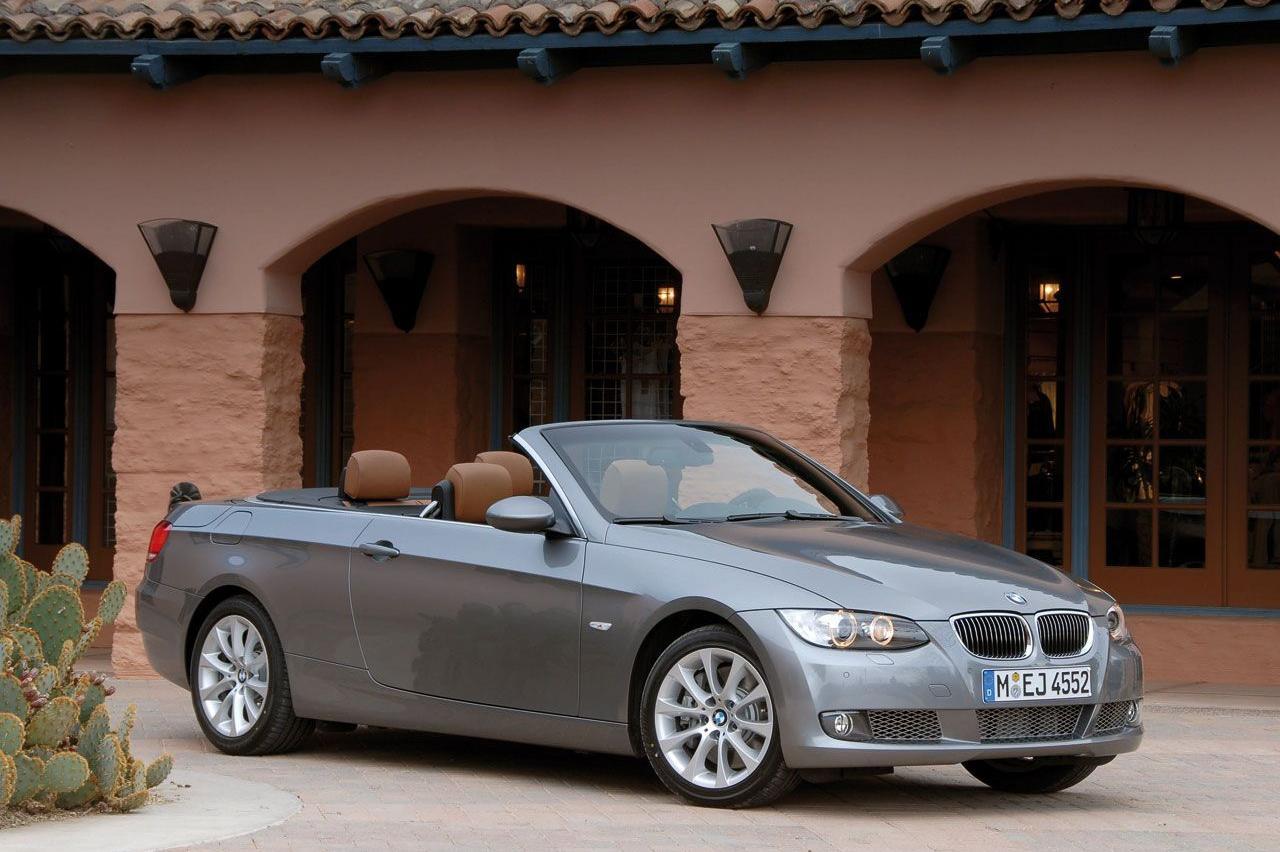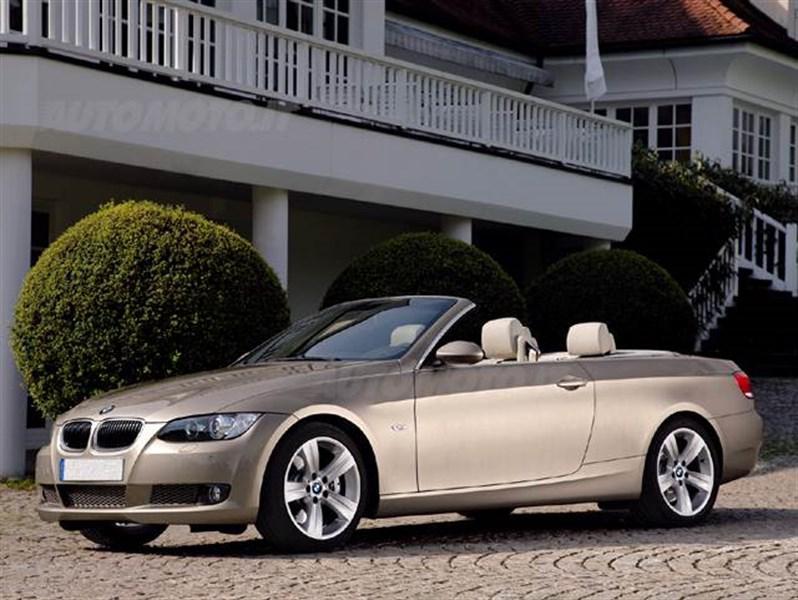The first image is the image on the left, the second image is the image on the right. Examine the images to the left and right. Is the description "In each image there is a convertible with its top down without any people present, but the cars are facing the opposite direction." accurate? Answer yes or no. Yes. The first image is the image on the left, the second image is the image on the right. Analyze the images presented: Is the assertion "Each image contains one topless convertible displayed at an angle, and the cars on the left and right are back-to-back, facing outward." valid? Answer yes or no. No. 